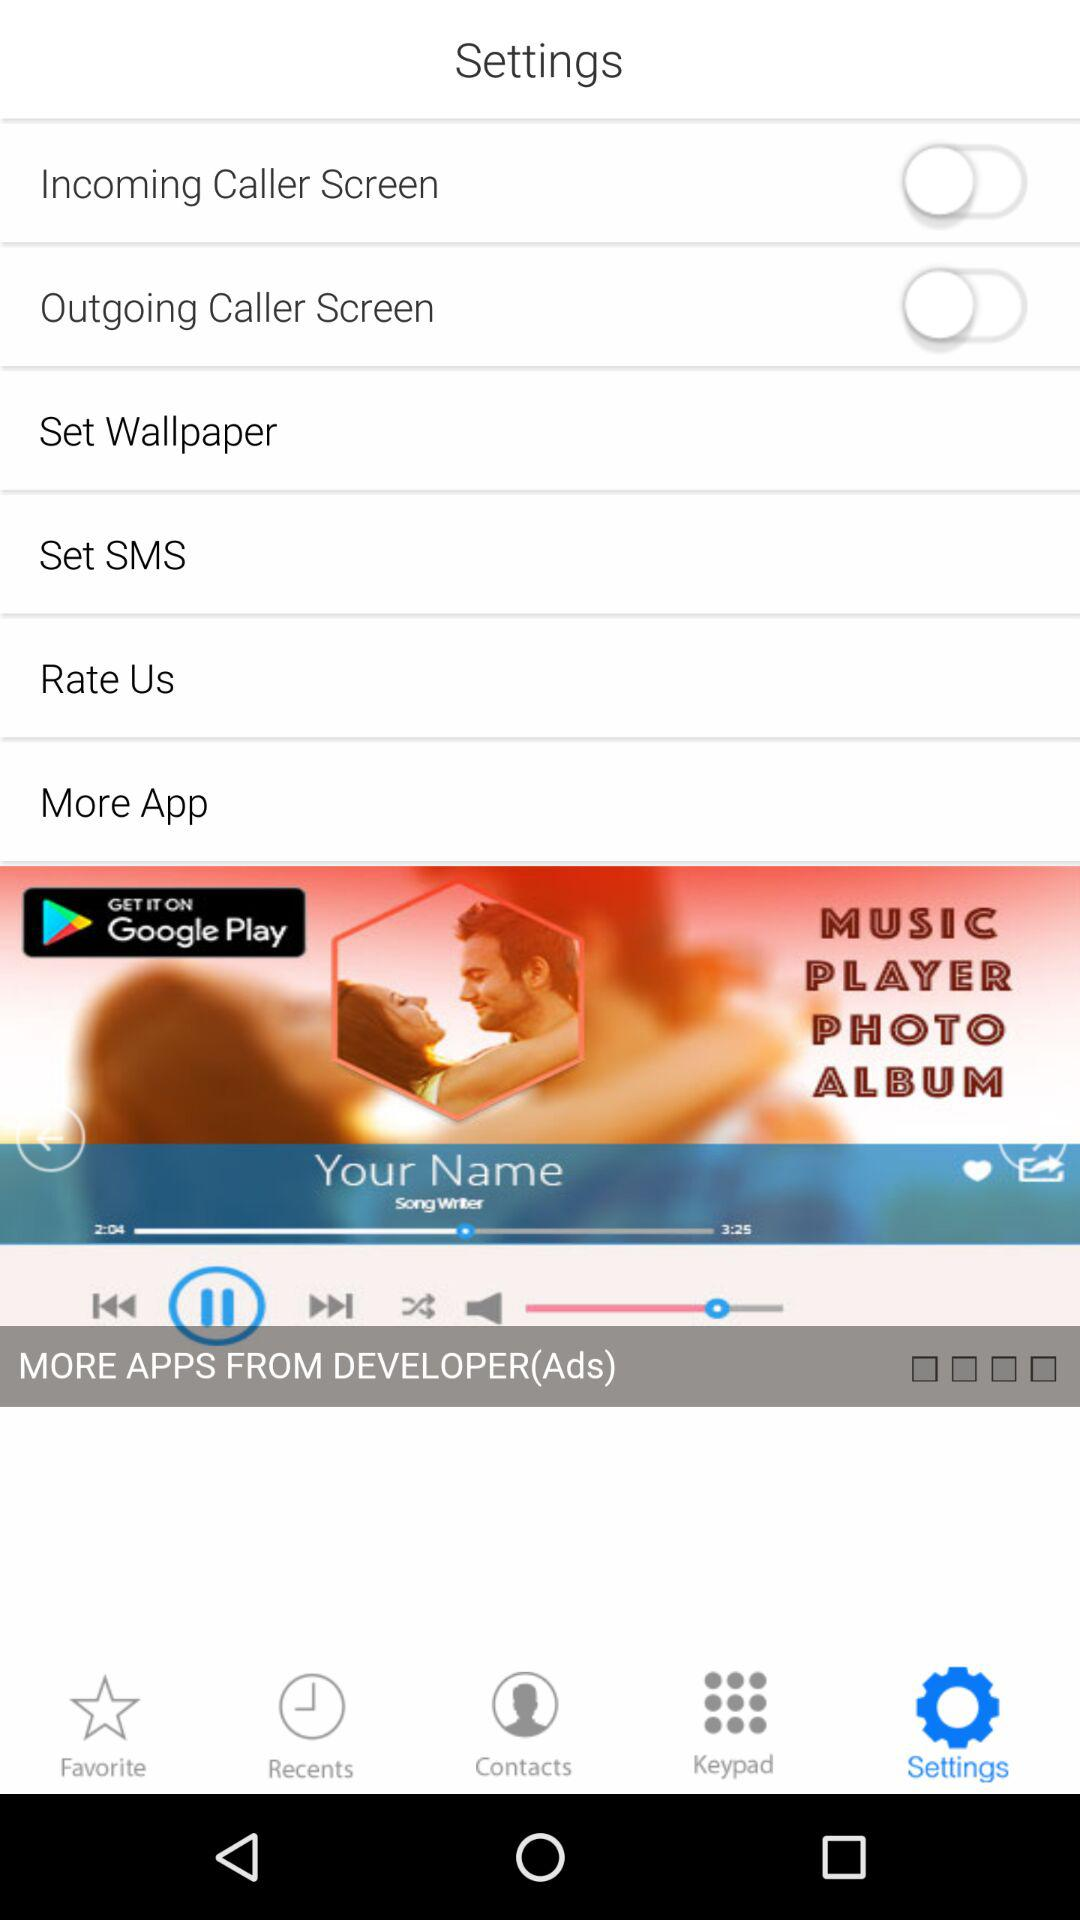What is the status of "Incoming Caller Screen"? The status is "off". 